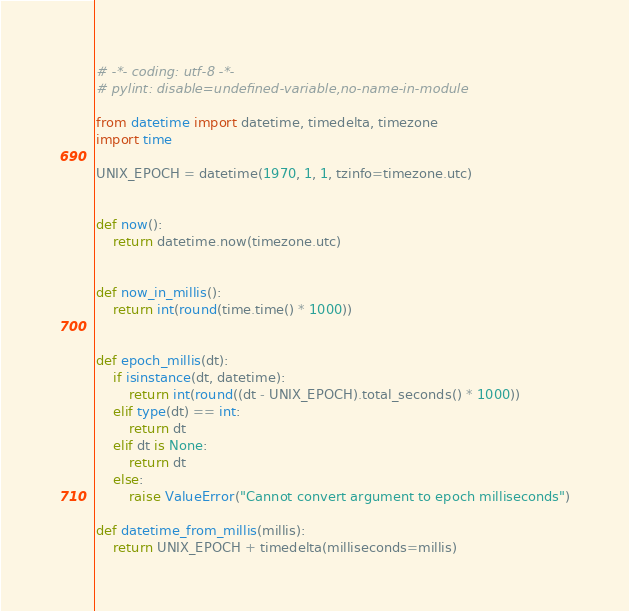Convert code to text. <code><loc_0><loc_0><loc_500><loc_500><_Python_># -*- coding: utf-8 -*-
# pylint: disable=undefined-variable,no-name-in-module

from datetime import datetime, timedelta, timezone
import time

UNIX_EPOCH = datetime(1970, 1, 1, tzinfo=timezone.utc)


def now():
    return datetime.now(timezone.utc)


def now_in_millis():
    return int(round(time.time() * 1000))


def epoch_millis(dt):
    if isinstance(dt, datetime):
        return int(round((dt - UNIX_EPOCH).total_seconds() * 1000))
    elif type(dt) == int:
        return dt
    elif dt is None:
        return dt
    else:
        raise ValueError("Cannot convert argument to epoch milliseconds")

def datetime_from_millis(millis):
    return UNIX_EPOCH + timedelta(milliseconds=millis)
</code> 